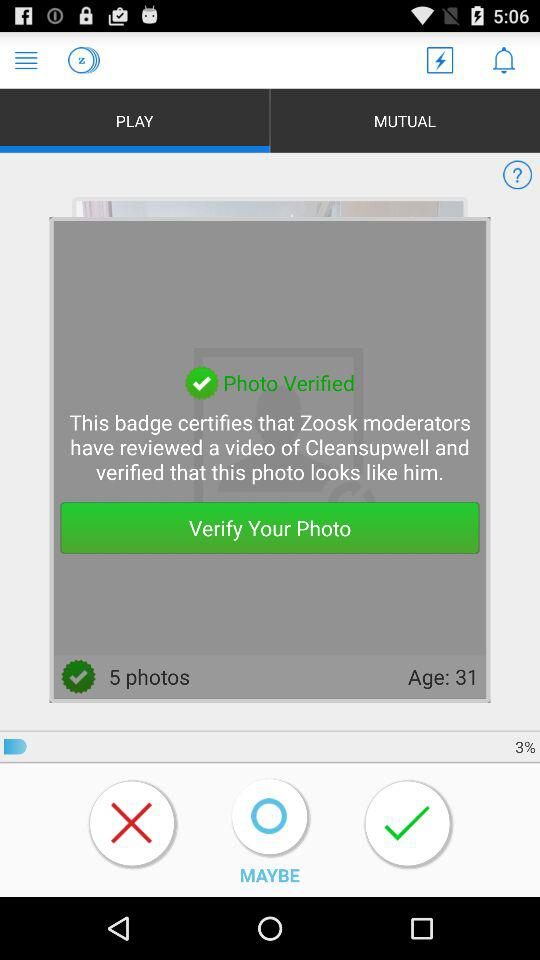How many photos does the user have?
Answer the question using a single word or phrase. 5 